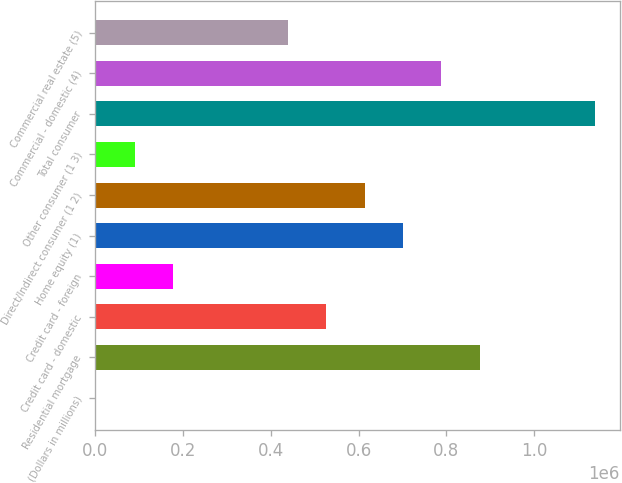<chart> <loc_0><loc_0><loc_500><loc_500><bar_chart><fcel>(Dollars in millions)<fcel>Residential mortgage<fcel>Credit card - domestic<fcel>Credit card - foreign<fcel>Home equity (1)<fcel>Direct/Indirect consumer (1 2)<fcel>Other consumer (1 3)<fcel>Total consumer<fcel>Commercial - domestic (4)<fcel>Commercial real estate (5)<nl><fcel>2007<fcel>876344<fcel>526609<fcel>176874<fcel>701477<fcel>614043<fcel>89440.7<fcel>1.13865e+06<fcel>788910<fcel>439176<nl></chart> 